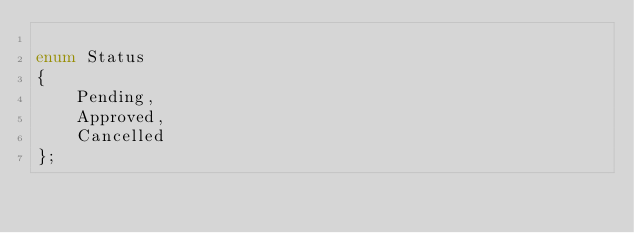Convert code to text. <code><loc_0><loc_0><loc_500><loc_500><_C_>
enum Status
{
	Pending,
	Approved,
	Cancelled
};
</code> 